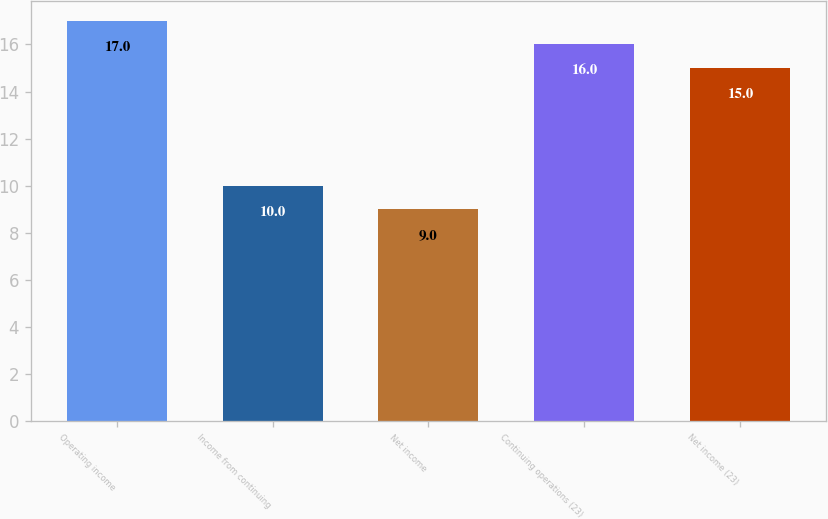<chart> <loc_0><loc_0><loc_500><loc_500><bar_chart><fcel>Operating income<fcel>Income from continuing<fcel>Net income<fcel>Continuing operations (23)<fcel>Net income (23)<nl><fcel>17<fcel>10<fcel>9<fcel>16<fcel>15<nl></chart> 